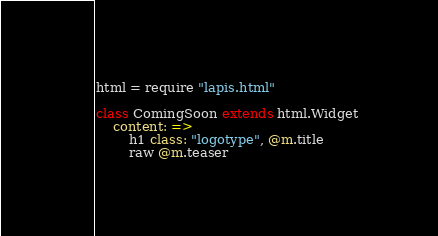Convert code to text. <code><loc_0><loc_0><loc_500><loc_500><_MoonScript_>html = require "lapis.html"

class ComingSoon extends html.Widget
    content: =>
        h1 class: "logotype", @m.title
        raw @m.teaser
</code> 